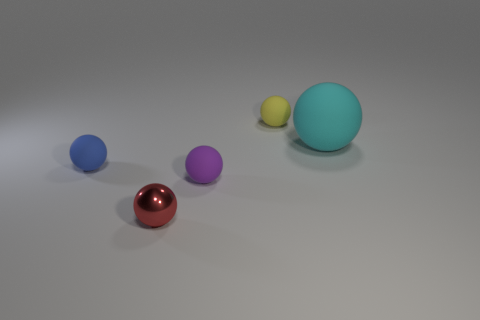Is there any other thing that is the same size as the cyan ball?
Provide a short and direct response. No. What material is the small yellow thing that is the same shape as the red metallic object?
Your answer should be very brief. Rubber. There is a small object that is both behind the tiny purple thing and on the right side of the red object; what material is it?
Offer a terse response. Rubber. Are there fewer tiny yellow things right of the small red object than tiny purple things that are behind the big sphere?
Make the answer very short. No. What number of other things are there of the same size as the purple rubber thing?
Provide a short and direct response. 3. What is the shape of the rubber thing that is behind the sphere on the right side of the small ball behind the large rubber thing?
Offer a very short reply. Sphere. How many red objects are metallic objects or big spheres?
Your answer should be compact. 1. There is a matte object in front of the small blue rubber ball; how many small rubber balls are on the right side of it?
Give a very brief answer. 1. Is there any other thing that is the same color as the large sphere?
Offer a very short reply. No. There is another big thing that is the same material as the yellow object; what shape is it?
Provide a succinct answer. Sphere. 